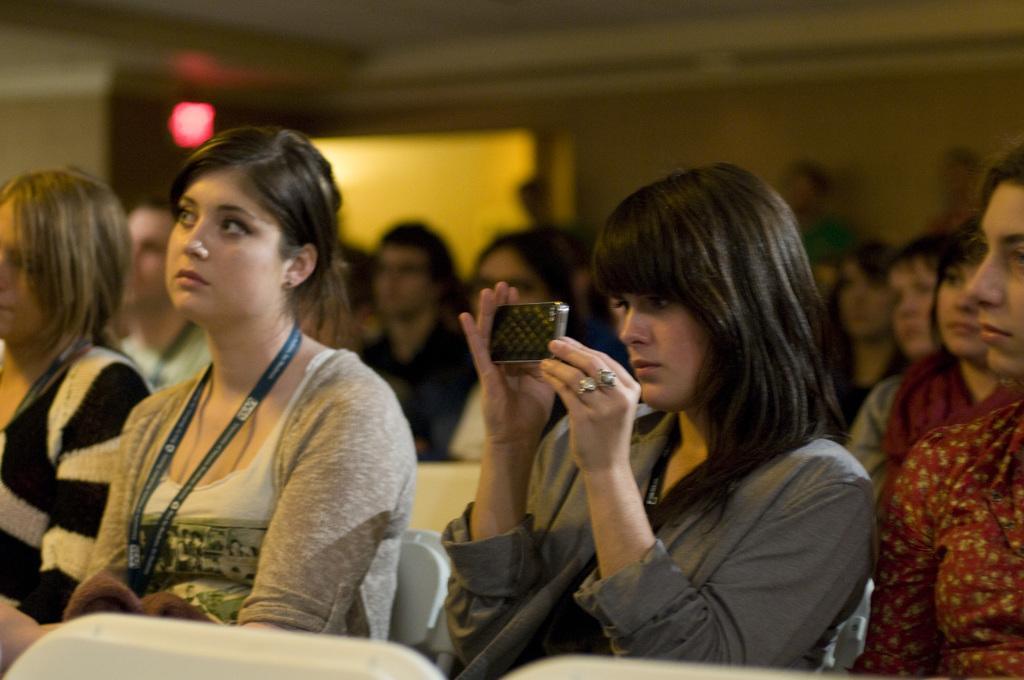Please provide a concise description of this image. In this picture I can see there are some people sitting and this person is looking into the smartphone and in the backdrop there is a wall, there are some persons standing. 